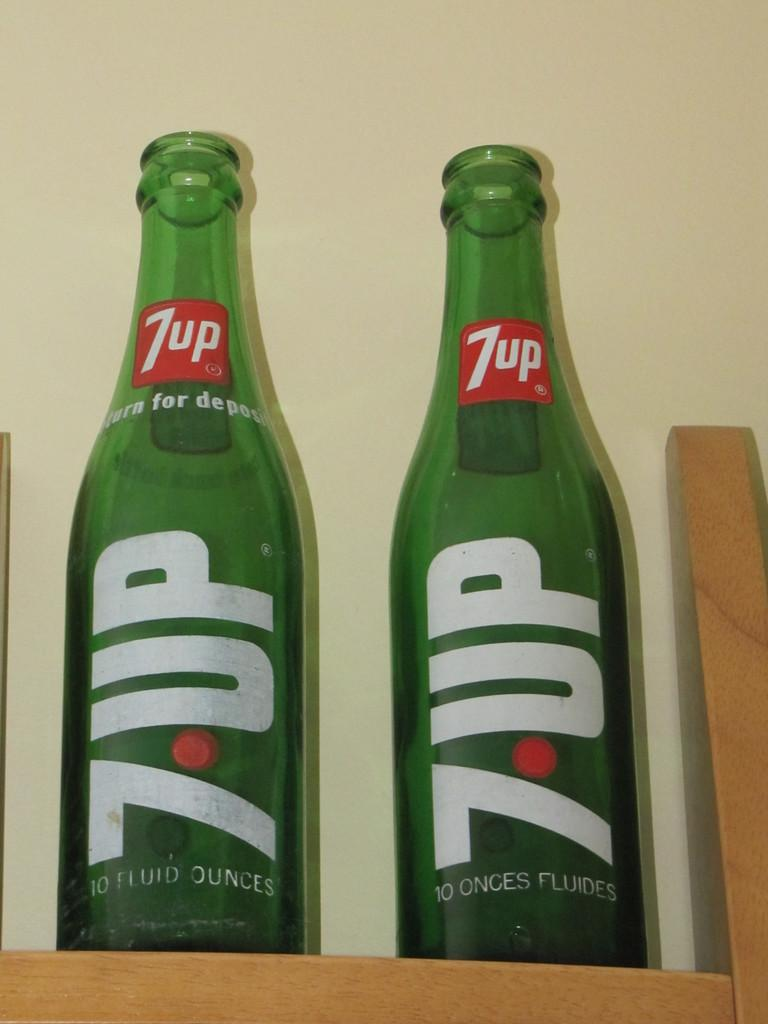<image>
Describe the image concisely. a bottle that has the number 7 on it 